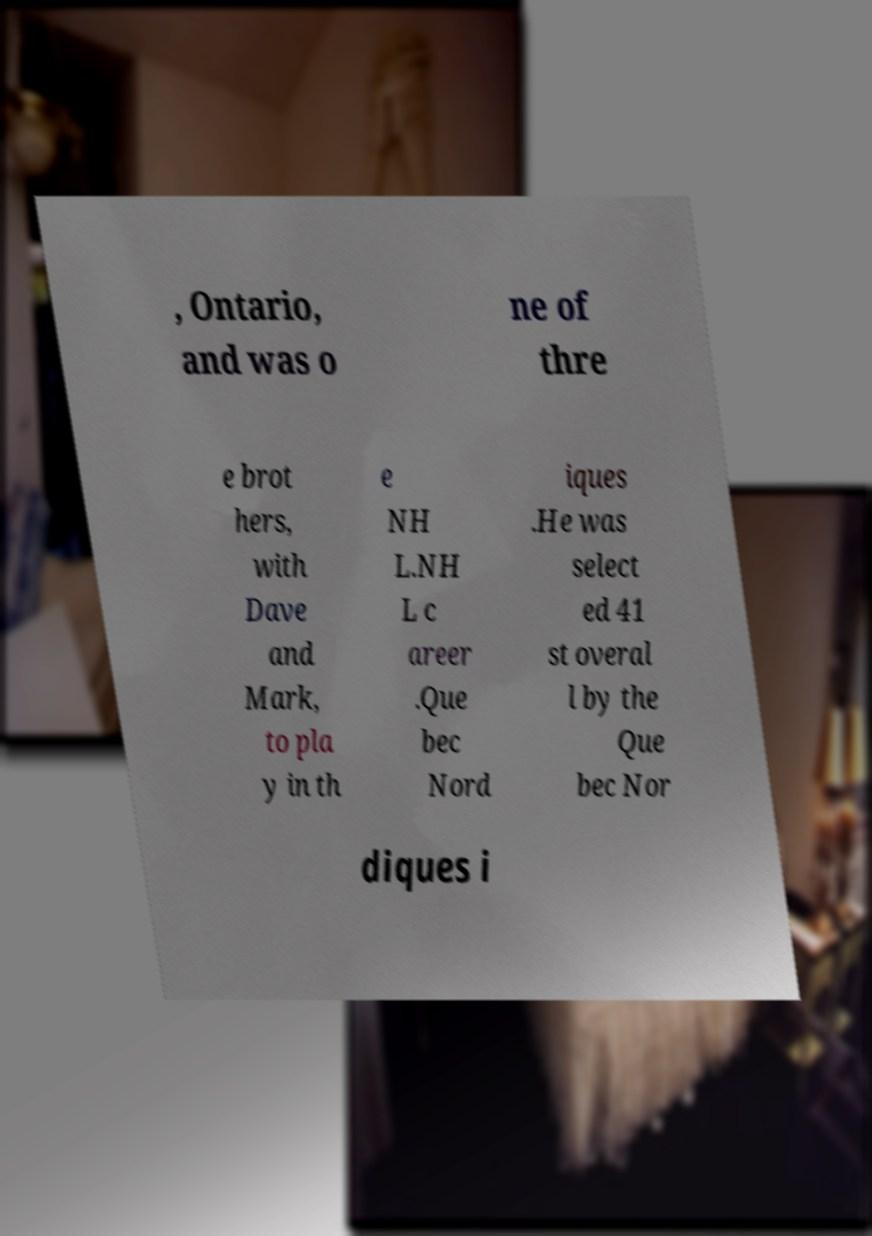Please identify and transcribe the text found in this image. , Ontario, and was o ne of thre e brot hers, with Dave and Mark, to pla y in th e NH L.NH L c areer .Que bec Nord iques .He was select ed 41 st overal l by the Que bec Nor diques i 